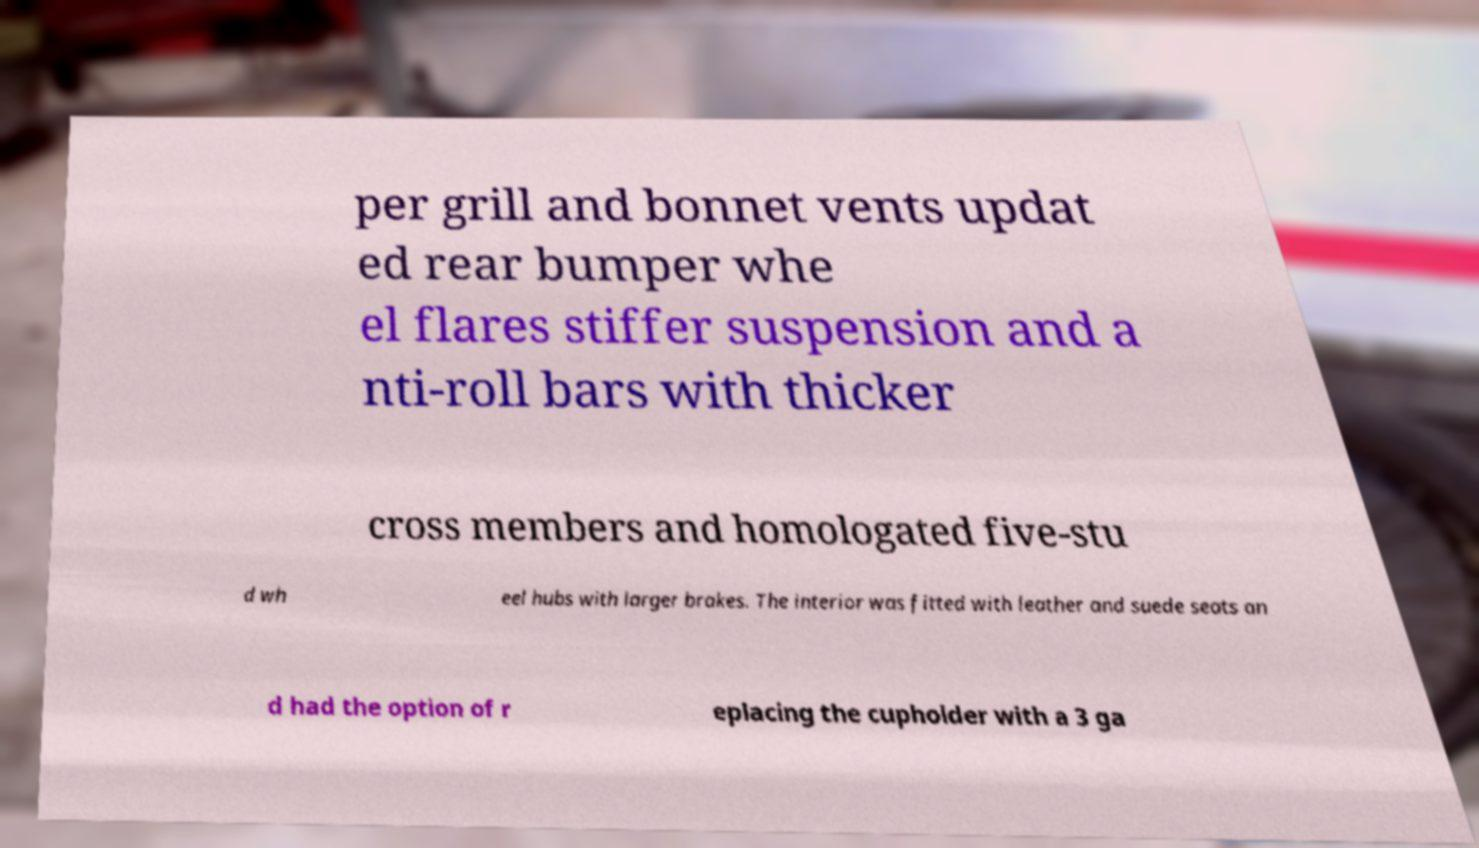I need the written content from this picture converted into text. Can you do that? per grill and bonnet vents updat ed rear bumper whe el flares stiffer suspension and a nti-roll bars with thicker cross members and homologated five-stu d wh eel hubs with larger brakes. The interior was fitted with leather and suede seats an d had the option of r eplacing the cupholder with a 3 ga 